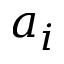<formula> <loc_0><loc_0><loc_500><loc_500>a _ { i }</formula> 